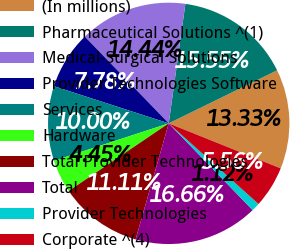<chart> <loc_0><loc_0><loc_500><loc_500><pie_chart><fcel>(In millions)<fcel>Pharmaceutical Solutions ^(1)<fcel>Medical-Surgical Solutions<fcel>Provider Technologies Software<fcel>Services<fcel>Hardware<fcel>Total Provider Technologies<fcel>Total<fcel>Provider Technologies<fcel>Corporate ^(4)<nl><fcel>13.33%<fcel>15.55%<fcel>14.44%<fcel>7.78%<fcel>10.0%<fcel>4.45%<fcel>11.11%<fcel>16.66%<fcel>1.12%<fcel>5.56%<nl></chart> 